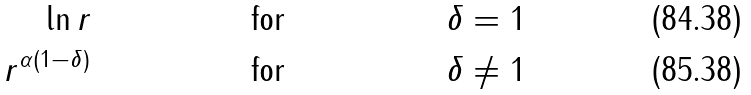<formula> <loc_0><loc_0><loc_500><loc_500>\ln r & \quad & \text {for} & \quad & \delta = 1 \\ r ^ { \alpha ( 1 - \delta ) } & \quad & \text {for} & \quad & \delta \neq 1</formula> 